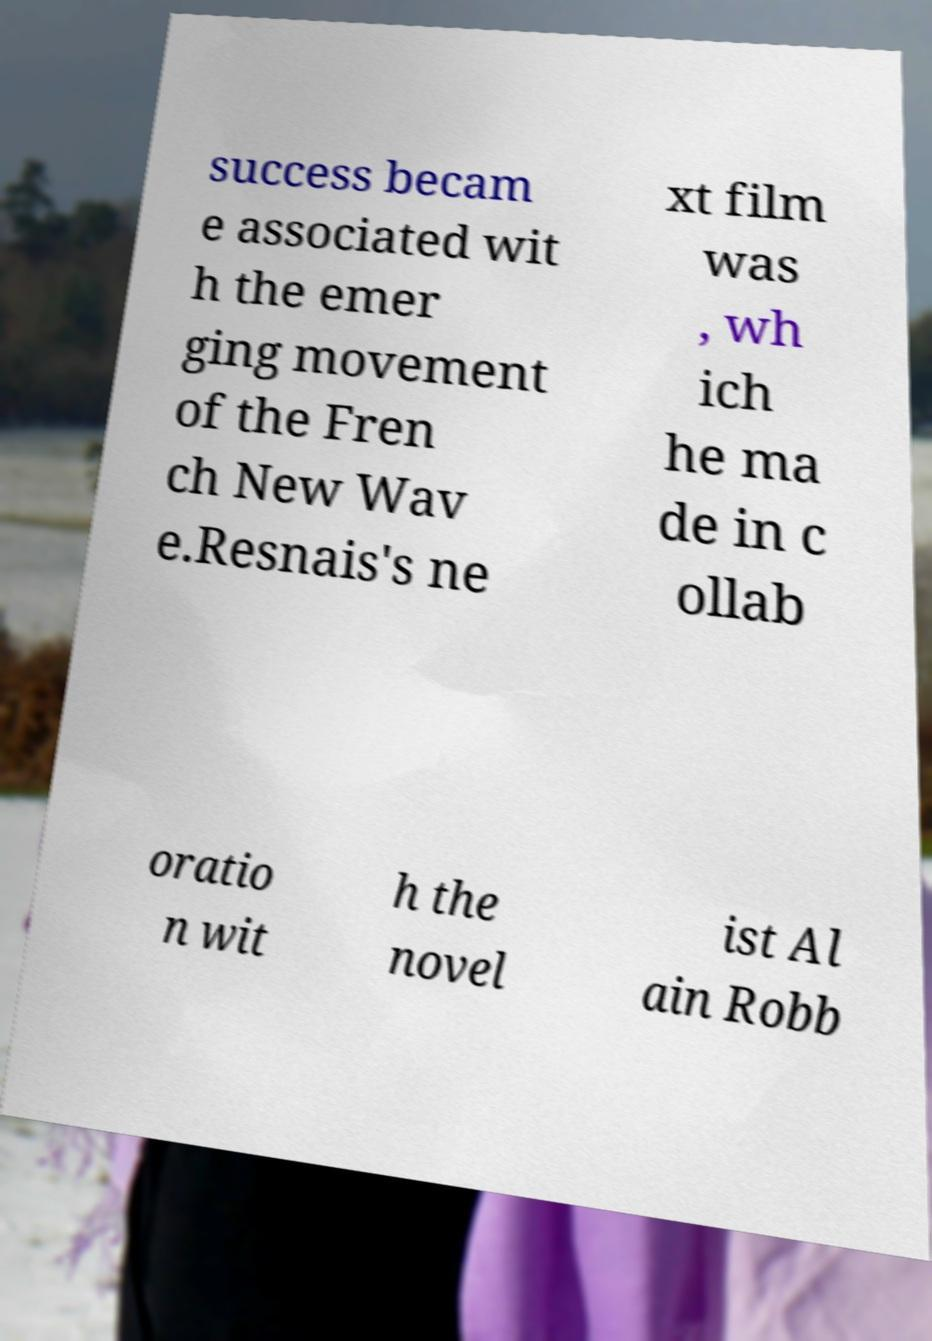Please read and relay the text visible in this image. What does it say? success becam e associated wit h the emer ging movement of the Fren ch New Wav e.Resnais's ne xt film was , wh ich he ma de in c ollab oratio n wit h the novel ist Al ain Robb 